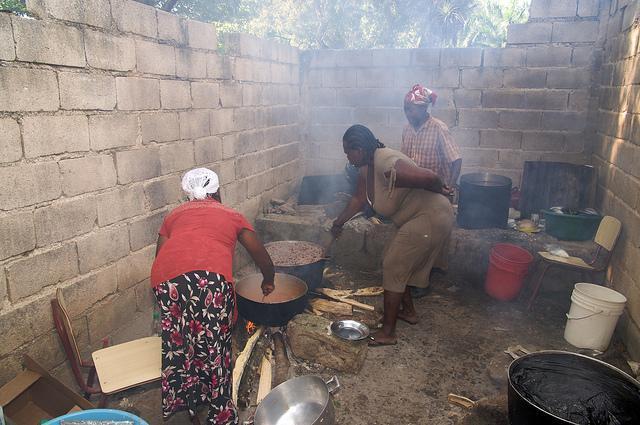How many people can be seen?
Give a very brief answer. 3. How many chairs are visible?
Give a very brief answer. 3. How many signs are hanging above the toilet that are not written in english?
Give a very brief answer. 0. 